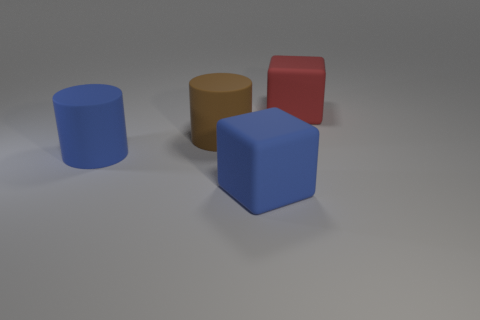Is the number of blue things that are to the left of the brown thing the same as the number of blue matte cylinders on the left side of the large blue matte cube?
Keep it short and to the point. Yes. Are there any brown cylinders that are left of the cube that is in front of the large red thing?
Keep it short and to the point. Yes. What is the shape of the large brown object that is the same material as the blue cylinder?
Your response must be concise. Cylinder. Is there another rubber object that has the same shape as the red matte object?
Keep it short and to the point. Yes. How many other objects are there of the same shape as the large brown thing?
Give a very brief answer. 1. There is a big thing that is both behind the blue cylinder and in front of the large red object; what shape is it?
Provide a succinct answer. Cylinder. There is a matte cube that is left of the red rubber block; how big is it?
Provide a succinct answer. Large. Do the blue cube and the brown rubber cylinder have the same size?
Provide a succinct answer. Yes. Is the number of big blue rubber things that are on the left side of the big red rubber object less than the number of objects behind the blue cube?
Provide a succinct answer. Yes. There is a thing that is both behind the blue cylinder and in front of the big red rubber object; what size is it?
Your response must be concise. Large. 